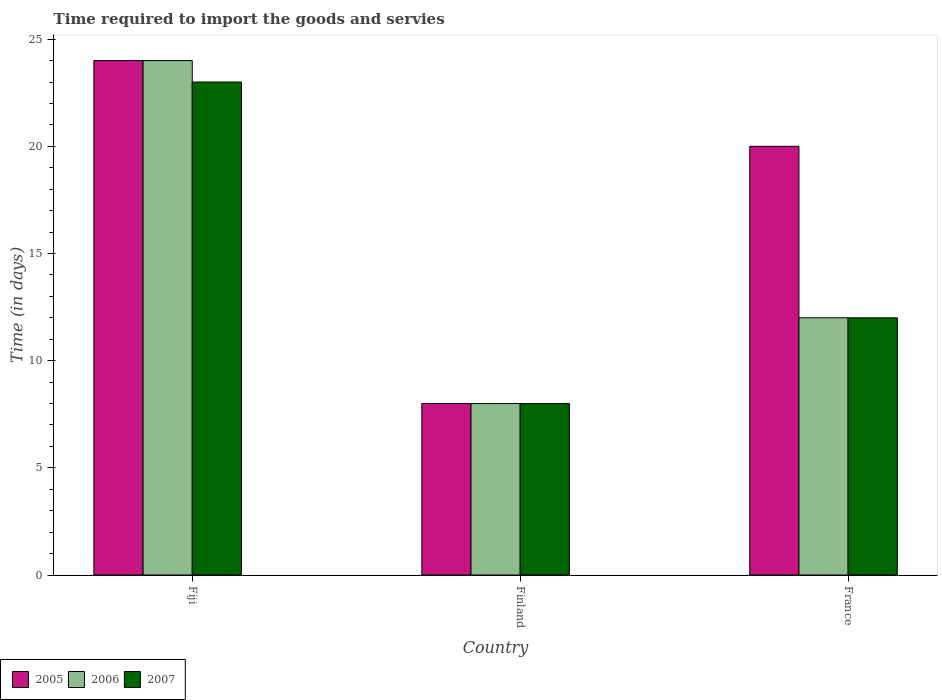How many groups of bars are there?
Your answer should be compact. 3. How many bars are there on the 2nd tick from the left?
Keep it short and to the point. 3. How many bars are there on the 1st tick from the right?
Provide a short and direct response. 3. What is the label of the 1st group of bars from the left?
Your response must be concise. Fiji. Across all countries, what is the minimum number of days required to import the goods and services in 2007?
Your answer should be very brief. 8. In which country was the number of days required to import the goods and services in 2006 maximum?
Offer a terse response. Fiji. What is the difference between the number of days required to import the goods and services in 2005 in Finland and that in France?
Your answer should be compact. -12. What is the average number of days required to import the goods and services in 2005 per country?
Your answer should be compact. 17.33. In how many countries, is the number of days required to import the goods and services in 2007 greater than 15 days?
Offer a very short reply. 1. Is the difference between the number of days required to import the goods and services in 2007 in Fiji and France greater than the difference between the number of days required to import the goods and services in 2005 in Fiji and France?
Your response must be concise. Yes. What is the difference between the highest and the second highest number of days required to import the goods and services in 2007?
Provide a short and direct response. -4. What is the difference between the highest and the lowest number of days required to import the goods and services in 2005?
Your answer should be compact. 16. What does the 2nd bar from the left in Fiji represents?
Provide a short and direct response. 2006. Does the graph contain any zero values?
Give a very brief answer. No. Does the graph contain grids?
Keep it short and to the point. No. Where does the legend appear in the graph?
Ensure brevity in your answer.  Bottom left. What is the title of the graph?
Your response must be concise. Time required to import the goods and servies. Does "2000" appear as one of the legend labels in the graph?
Provide a short and direct response. No. What is the label or title of the X-axis?
Keep it short and to the point. Country. What is the label or title of the Y-axis?
Offer a terse response. Time (in days). What is the Time (in days) in 2005 in Fiji?
Provide a short and direct response. 24. What is the Time (in days) in 2006 in Fiji?
Your answer should be very brief. 24. What is the Time (in days) in 2006 in Finland?
Provide a short and direct response. 8. What is the Time (in days) of 2006 in France?
Your response must be concise. 12. What is the Time (in days) of 2007 in France?
Your answer should be compact. 12. Across all countries, what is the maximum Time (in days) of 2007?
Your response must be concise. 23. Across all countries, what is the minimum Time (in days) of 2007?
Offer a terse response. 8. What is the total Time (in days) of 2005 in the graph?
Your response must be concise. 52. What is the total Time (in days) of 2006 in the graph?
Offer a very short reply. 44. What is the difference between the Time (in days) in 2005 in Fiji and that in Finland?
Your answer should be very brief. 16. What is the difference between the Time (in days) in 2006 in Fiji and that in France?
Offer a terse response. 12. What is the difference between the Time (in days) of 2007 in Fiji and that in France?
Offer a terse response. 11. What is the difference between the Time (in days) of 2007 in Finland and that in France?
Offer a terse response. -4. What is the difference between the Time (in days) in 2005 in Fiji and the Time (in days) in 2007 in Finland?
Keep it short and to the point. 16. What is the difference between the Time (in days) of 2005 in Fiji and the Time (in days) of 2007 in France?
Give a very brief answer. 12. What is the difference between the Time (in days) in 2006 in Fiji and the Time (in days) in 2007 in France?
Offer a terse response. 12. What is the difference between the Time (in days) of 2005 in Finland and the Time (in days) of 2006 in France?
Provide a short and direct response. -4. What is the difference between the Time (in days) in 2006 in Finland and the Time (in days) in 2007 in France?
Make the answer very short. -4. What is the average Time (in days) in 2005 per country?
Ensure brevity in your answer.  17.33. What is the average Time (in days) of 2006 per country?
Make the answer very short. 14.67. What is the average Time (in days) in 2007 per country?
Make the answer very short. 14.33. What is the difference between the Time (in days) of 2005 and Time (in days) of 2006 in Fiji?
Keep it short and to the point. 0. What is the difference between the Time (in days) in 2005 and Time (in days) in 2007 in Fiji?
Your answer should be very brief. 1. What is the difference between the Time (in days) in 2006 and Time (in days) in 2007 in Finland?
Keep it short and to the point. 0. What is the difference between the Time (in days) of 2005 and Time (in days) of 2007 in France?
Your response must be concise. 8. What is the ratio of the Time (in days) in 2006 in Fiji to that in Finland?
Your response must be concise. 3. What is the ratio of the Time (in days) of 2007 in Fiji to that in Finland?
Your answer should be compact. 2.88. What is the ratio of the Time (in days) of 2007 in Fiji to that in France?
Offer a very short reply. 1.92. What is the ratio of the Time (in days) in 2007 in Finland to that in France?
Offer a terse response. 0.67. What is the difference between the highest and the second highest Time (in days) in 2005?
Keep it short and to the point. 4. What is the difference between the highest and the second highest Time (in days) in 2007?
Your response must be concise. 11. What is the difference between the highest and the lowest Time (in days) of 2005?
Offer a very short reply. 16. What is the difference between the highest and the lowest Time (in days) of 2006?
Your response must be concise. 16. 